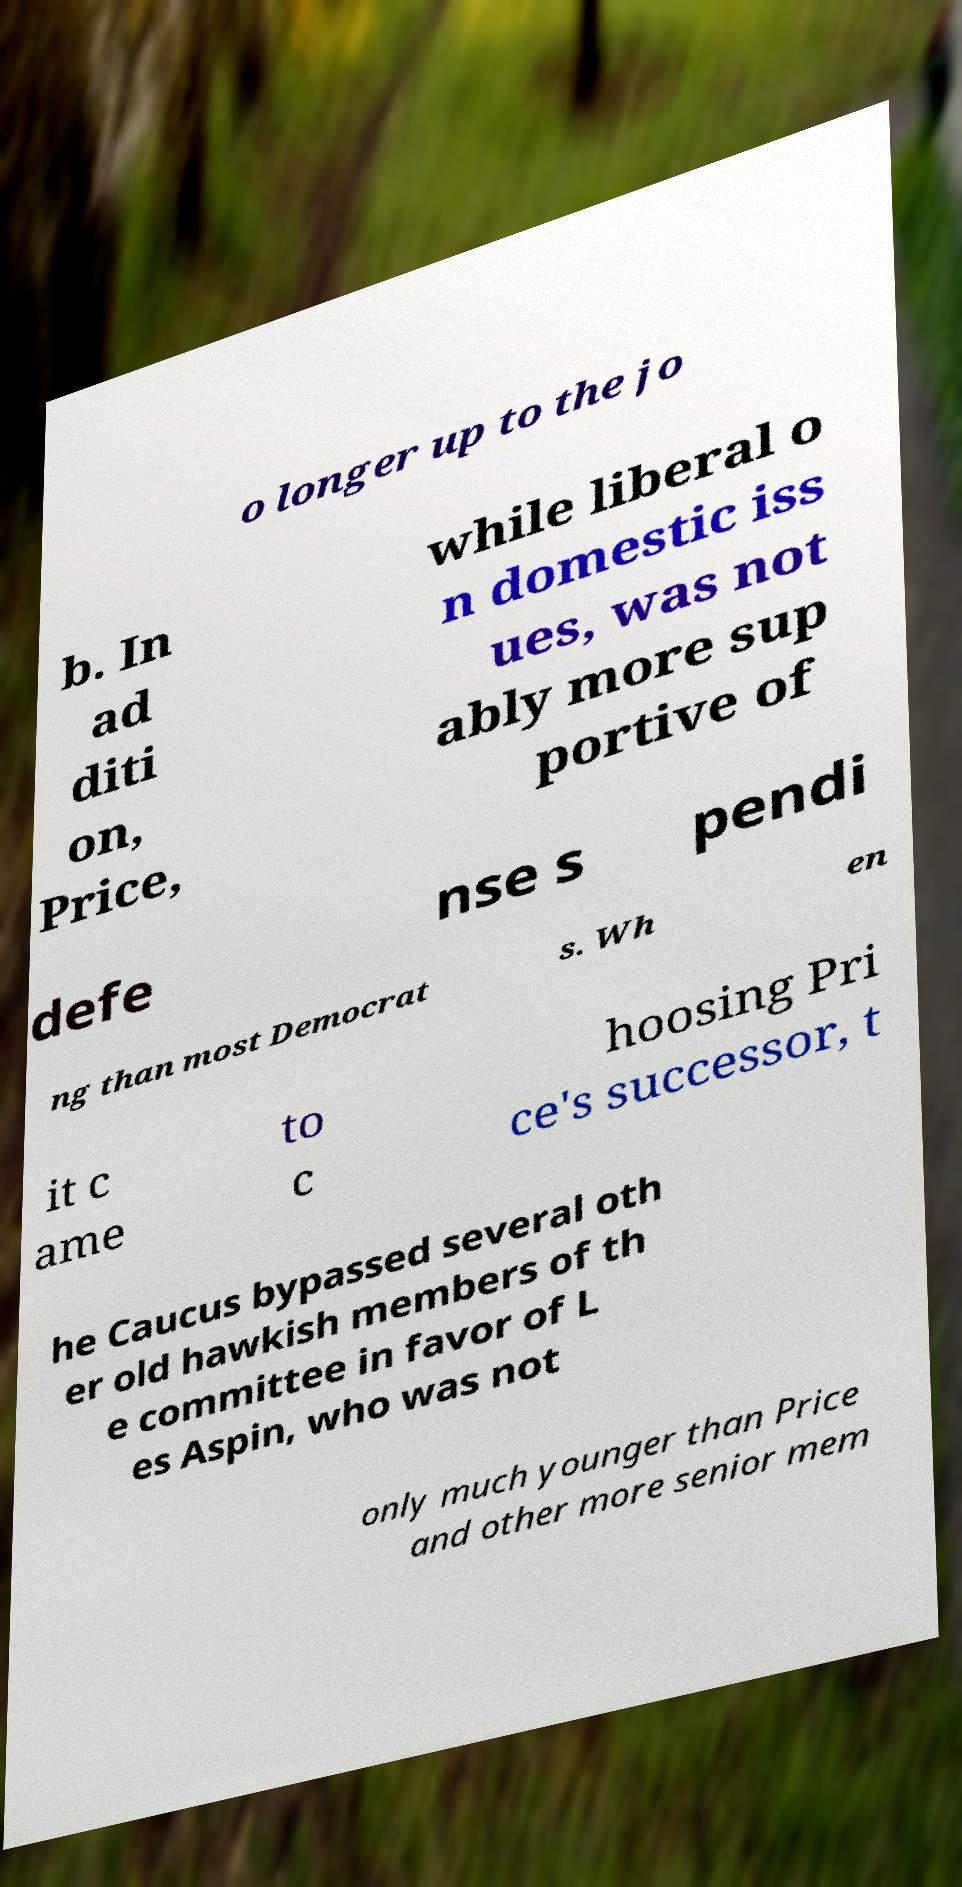Could you extract and type out the text from this image? o longer up to the jo b. In ad diti on, Price, while liberal o n domestic iss ues, was not ably more sup portive of defe nse s pendi ng than most Democrat s. Wh en it c ame to c hoosing Pri ce's successor, t he Caucus bypassed several oth er old hawkish members of th e committee in favor of L es Aspin, who was not only much younger than Price and other more senior mem 